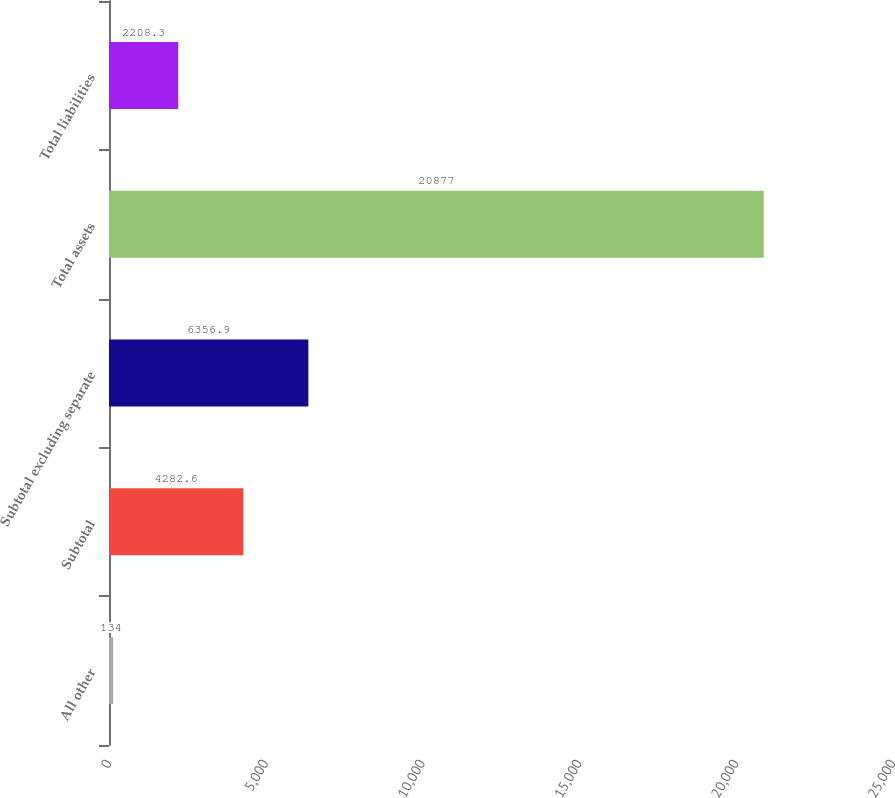Convert chart. <chart><loc_0><loc_0><loc_500><loc_500><bar_chart><fcel>All other<fcel>Subtotal<fcel>Subtotal excluding separate<fcel>Total assets<fcel>Total liabilities<nl><fcel>134<fcel>4282.6<fcel>6356.9<fcel>20877<fcel>2208.3<nl></chart> 